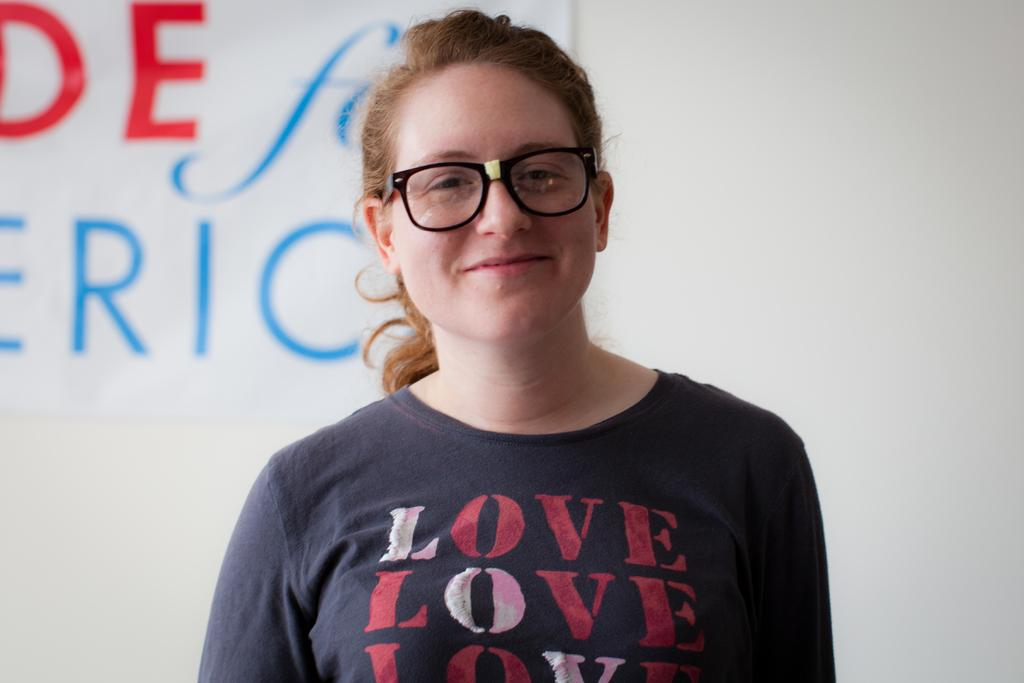Who is the main subject in the image? There is a girl in the image. Where is the girl positioned in the image? The girl is standing in the middle of the image. What is the girl wearing that is noticeable? The girl is wearing black color spectacles. What can be seen in the background of the image? There is a wall in the background of the image, and a banner is attached to the wall. How many sacks are visible in the image? There are no sacks present in the image. What type of spiders can be seen crawling on the girl's spectacles? There are no spiders present in the image, and the girl is wearing spectacles, not spiders. 